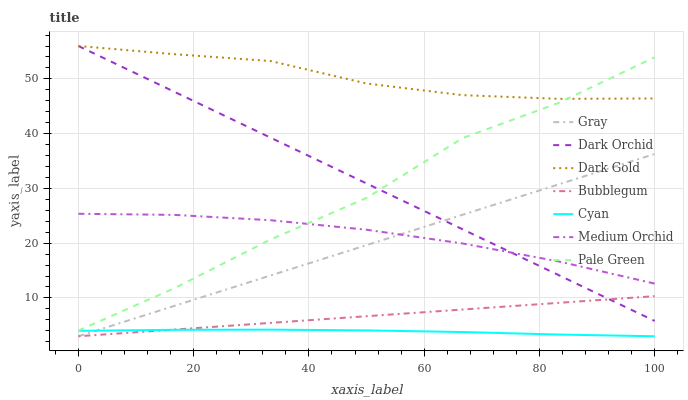Does Cyan have the minimum area under the curve?
Answer yes or no. Yes. Does Dark Gold have the maximum area under the curve?
Answer yes or no. Yes. Does Medium Orchid have the minimum area under the curve?
Answer yes or no. No. Does Medium Orchid have the maximum area under the curve?
Answer yes or no. No. Is Bubblegum the smoothest?
Answer yes or no. Yes. Is Pale Green the roughest?
Answer yes or no. Yes. Is Dark Gold the smoothest?
Answer yes or no. No. Is Dark Gold the roughest?
Answer yes or no. No. Does Gray have the lowest value?
Answer yes or no. Yes. Does Medium Orchid have the lowest value?
Answer yes or no. No. Does Dark Orchid have the highest value?
Answer yes or no. Yes. Does Medium Orchid have the highest value?
Answer yes or no. No. Is Bubblegum less than Pale Green?
Answer yes or no. Yes. Is Dark Orchid greater than Cyan?
Answer yes or no. Yes. Does Pale Green intersect Dark Gold?
Answer yes or no. Yes. Is Pale Green less than Dark Gold?
Answer yes or no. No. Is Pale Green greater than Dark Gold?
Answer yes or no. No. Does Bubblegum intersect Pale Green?
Answer yes or no. No. 